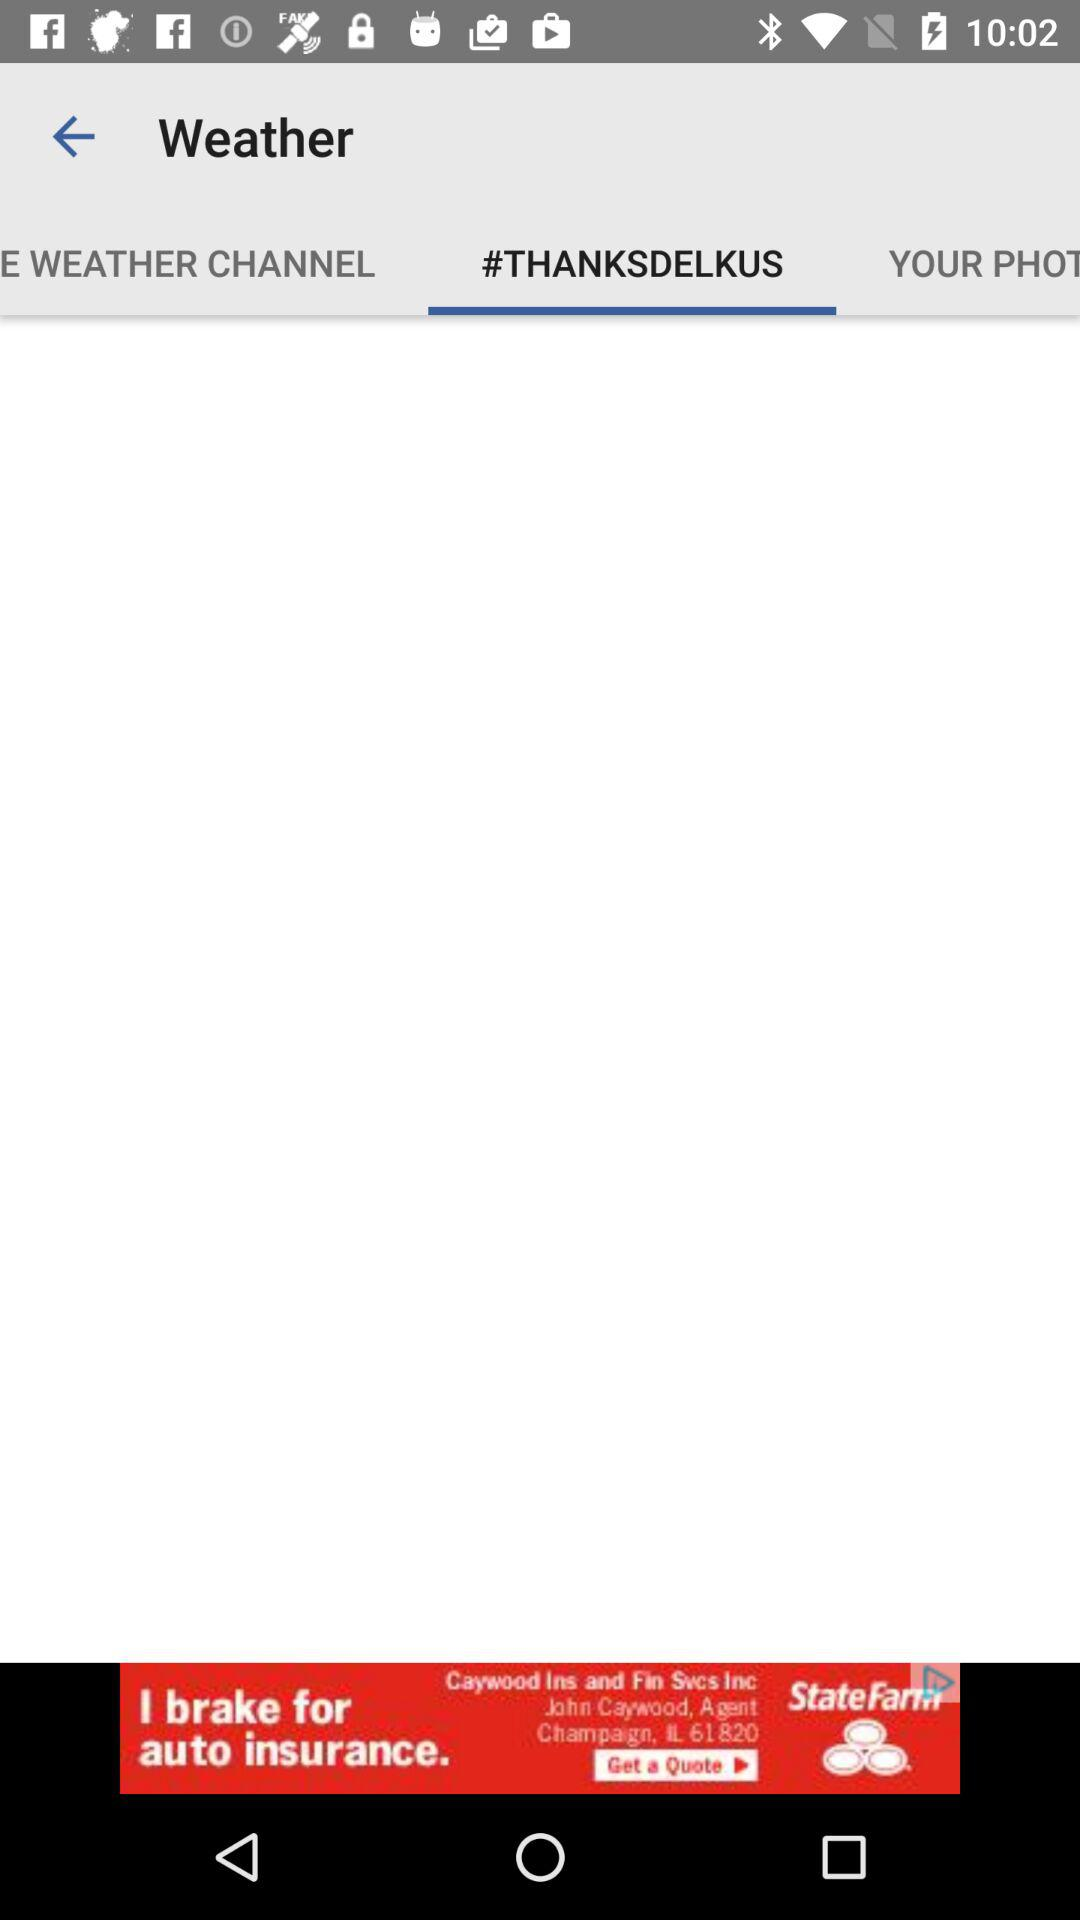Which tab is currently selected? The currently selected tab is "#THANKSDELKUS". 